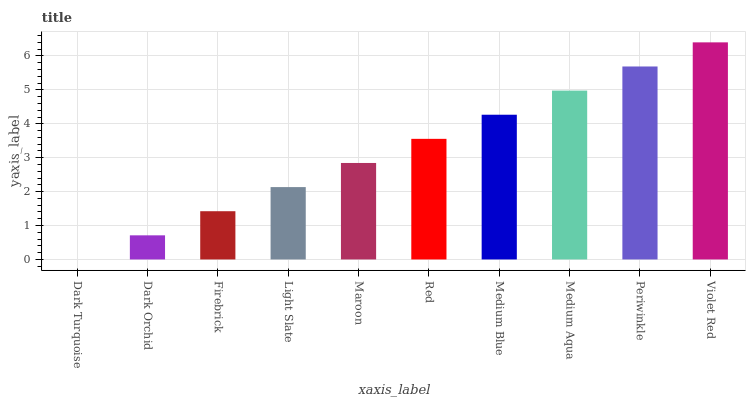Is Dark Turquoise the minimum?
Answer yes or no. Yes. Is Violet Red the maximum?
Answer yes or no. Yes. Is Dark Orchid the minimum?
Answer yes or no. No. Is Dark Orchid the maximum?
Answer yes or no. No. Is Dark Orchid greater than Dark Turquoise?
Answer yes or no. Yes. Is Dark Turquoise less than Dark Orchid?
Answer yes or no. Yes. Is Dark Turquoise greater than Dark Orchid?
Answer yes or no. No. Is Dark Orchid less than Dark Turquoise?
Answer yes or no. No. Is Red the high median?
Answer yes or no. Yes. Is Maroon the low median?
Answer yes or no. Yes. Is Dark Orchid the high median?
Answer yes or no. No. Is Violet Red the low median?
Answer yes or no. No. 